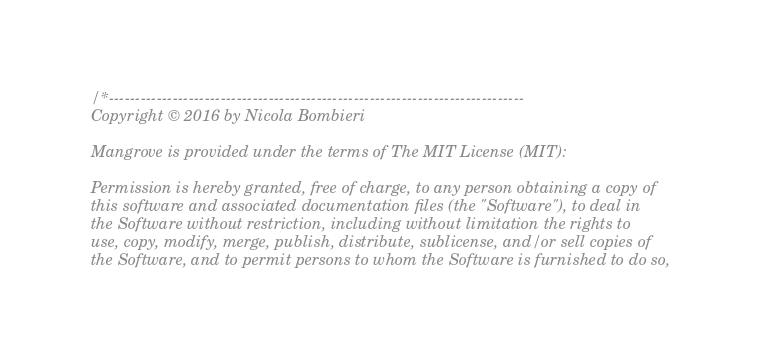<code> <loc_0><loc_0><loc_500><loc_500><_Cuda_>/*------------------------------------------------------------------------------
Copyright © 2016 by Nicola Bombieri

Mangrove is provided under the terms of The MIT License (MIT):

Permission is hereby granted, free of charge, to any person obtaining a copy of
this software and associated documentation files (the "Software"), to deal in
the Software without restriction, including without limitation the rights to
use, copy, modify, merge, publish, distribute, sublicense, and/or sell copies of
the Software, and to permit persons to whom the Software is furnished to do so,</code> 